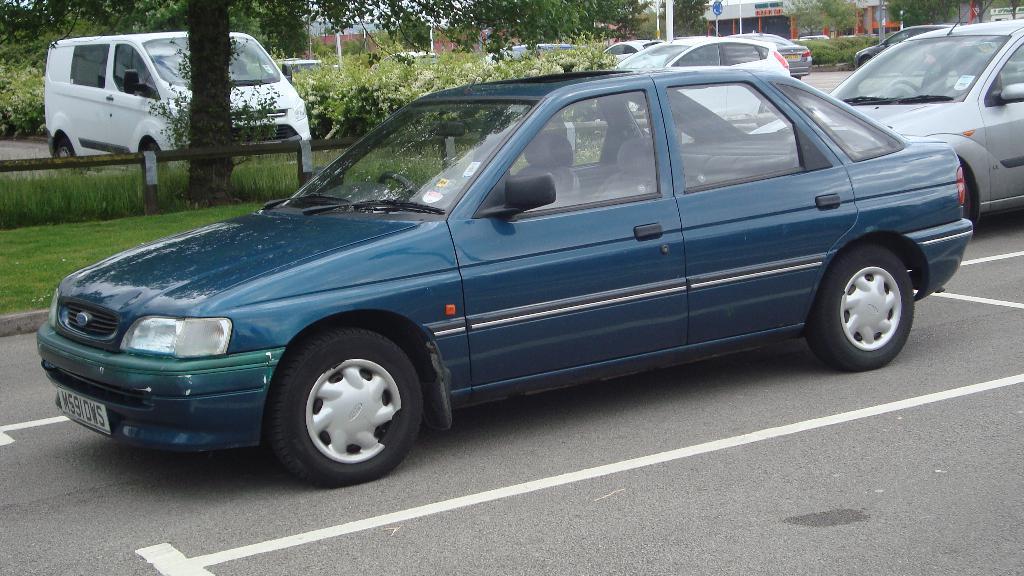Describe this image in one or two sentences. In this picture we can see vehicles on the road and in the background we can see trees. 